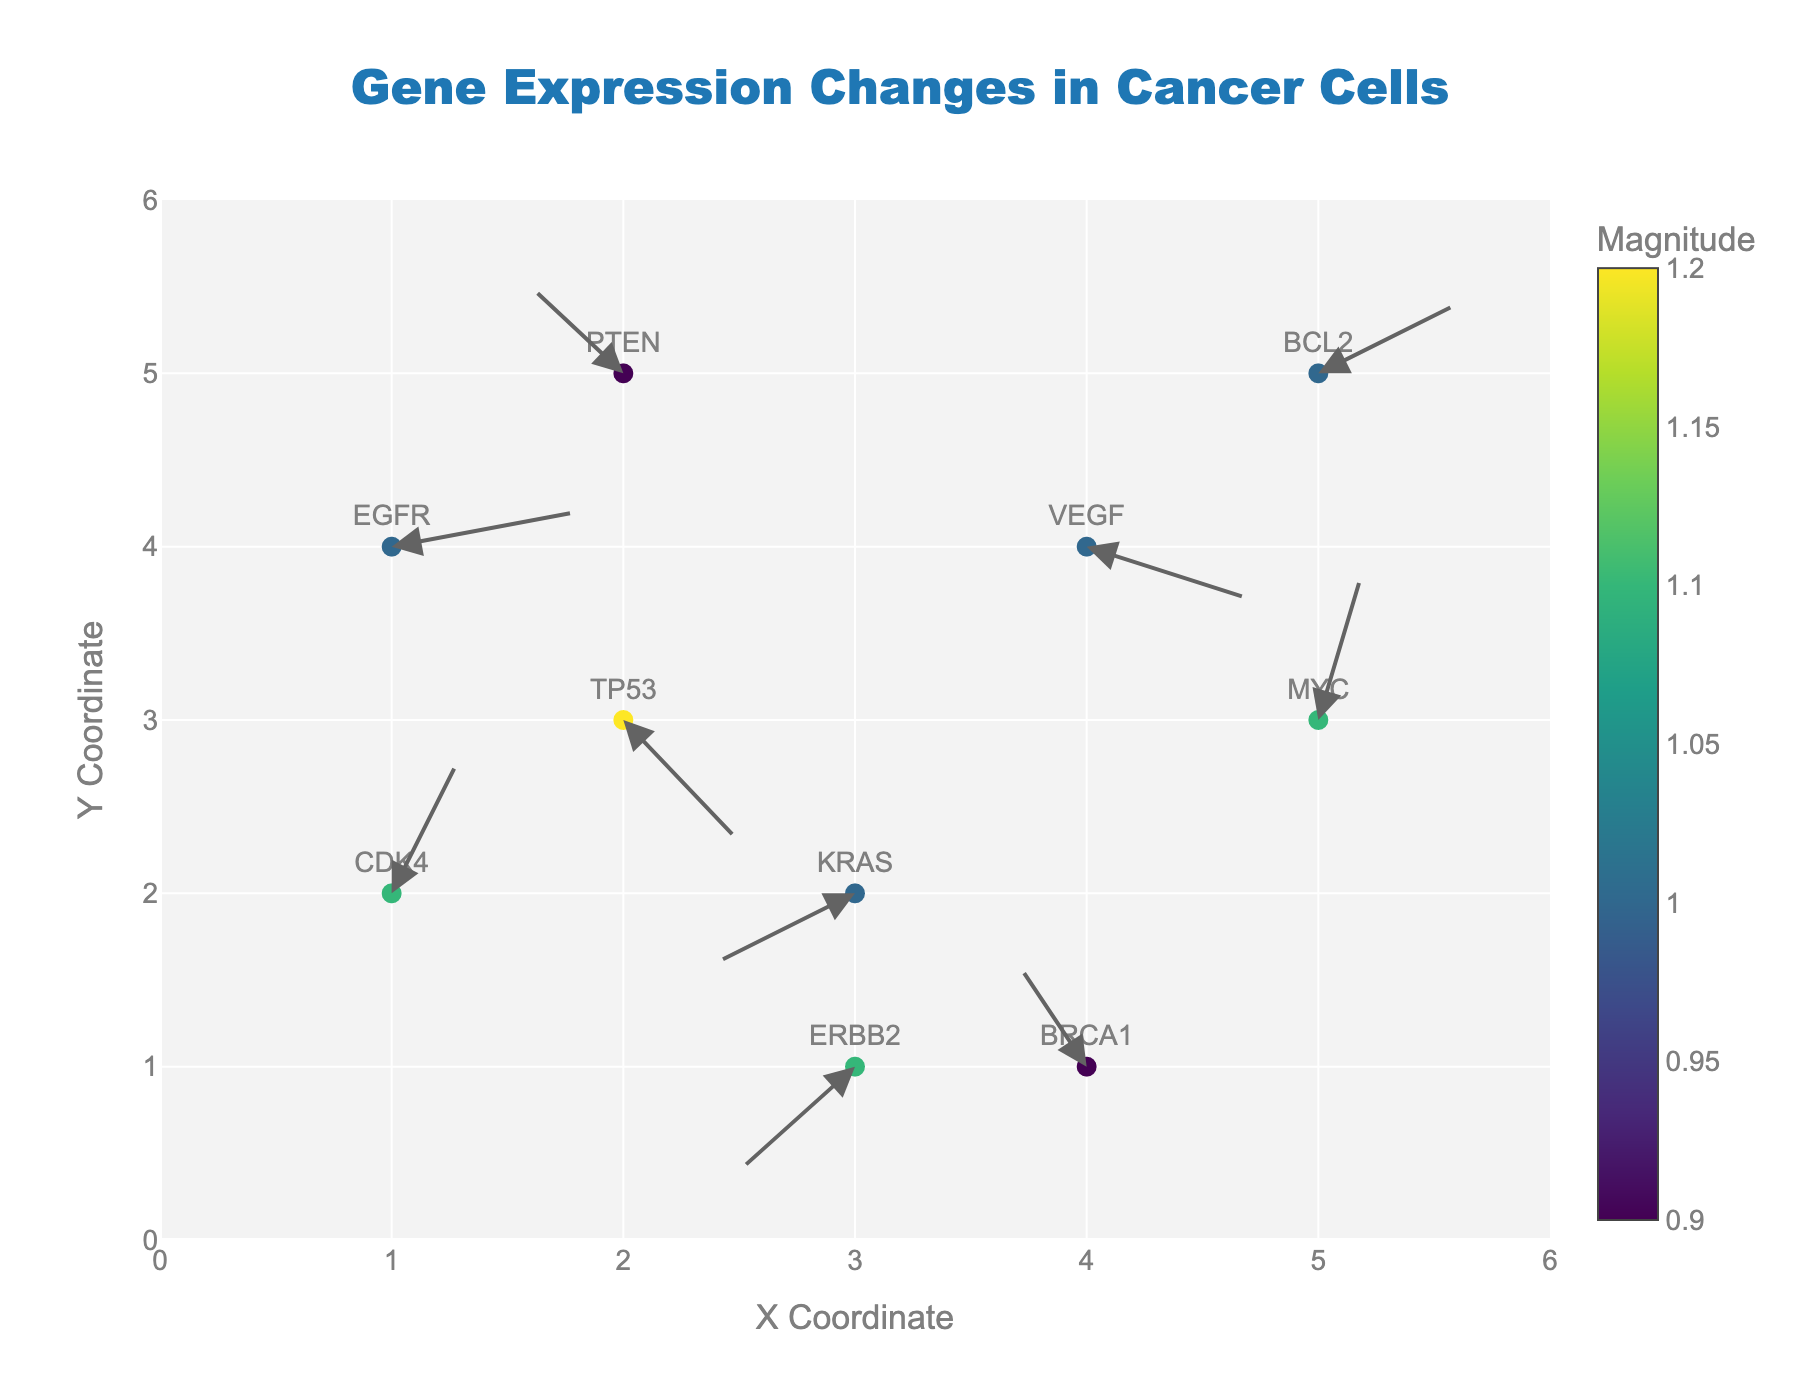What is the title of the figure? The title is located at the top of the figure and is typically in larger, bold font.
Answer: Gene Expression Changes in Cancer Cells Which axis measures the X coordinates? The X-axis is the horizontal axis in the figure. It runs from left to right.
Answer: X Coordinate How many genes are represented in the figure? There are markers in the figure with gene labels for each one. Count the unique gene labels.
Answer: 10 Which gene has the largest magnitude of regulatory effect? The magnitude of regulatory effect can be interpreted from the color scale. The gene with the darkest color (highest value on the color scale) has the largest effect. Compare the colors of the markers for each gene.
Answer: EGFR What are the coordinates and vector components for the gene TP53? Look for the marker labeled TP53 and check the hover text or annotation for its coordinates and vector components.
Answer: x: 2, y: 3, u: 0.5, v: -0.7 Which gene has a positive change in both X and Y coordinates? Find the genes where both vector components (u,v) are positive. These are the genes moving up and to the right.
Answer: EGFR, CDK4, MYC What is the vector direction for the gene KRAS? The vector direction can be determined by the (u,v) components. Look for KRAS and note its components.
Answer: (-0.6, -0.4), which means it moves to the left and down Which gene shows a decrease in the Y coordinate but an increase in the X coordinate? Identify genes where the Y component (v) is negative and the X component (u) is positive.
Answer: TP53, VEGF What is the average X coordinate of all the genes? Sum up all X coordinates for the genes and divide by the total number of genes. (2+4+1+3+5+2+4+1+3+5) / 10
Answer: 3.0 